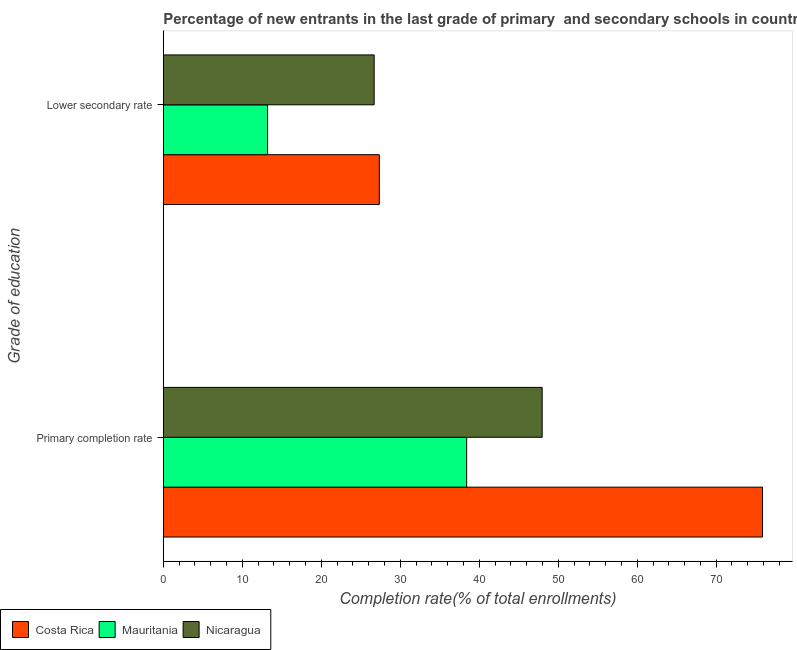How many different coloured bars are there?
Offer a very short reply. 3. How many groups of bars are there?
Provide a short and direct response. 2. How many bars are there on the 2nd tick from the top?
Give a very brief answer. 3. What is the label of the 1st group of bars from the top?
Provide a short and direct response. Lower secondary rate. What is the completion rate in primary schools in Costa Rica?
Your answer should be compact. 75.87. Across all countries, what is the maximum completion rate in primary schools?
Provide a short and direct response. 75.87. Across all countries, what is the minimum completion rate in secondary schools?
Your answer should be compact. 13.21. In which country was the completion rate in primary schools maximum?
Provide a succinct answer. Costa Rica. In which country was the completion rate in secondary schools minimum?
Provide a succinct answer. Mauritania. What is the total completion rate in primary schools in the graph?
Your response must be concise. 162.25. What is the difference between the completion rate in primary schools in Nicaragua and that in Mauritania?
Make the answer very short. 9.56. What is the difference between the completion rate in primary schools in Nicaragua and the completion rate in secondary schools in Mauritania?
Offer a very short reply. 34.76. What is the average completion rate in secondary schools per country?
Your answer should be compact. 22.42. What is the difference between the completion rate in secondary schools and completion rate in primary schools in Nicaragua?
Ensure brevity in your answer.  -21.27. In how many countries, is the completion rate in primary schools greater than 44 %?
Your answer should be very brief. 2. What is the ratio of the completion rate in primary schools in Costa Rica to that in Mauritania?
Your response must be concise. 1.98. What does the 2nd bar from the top in Lower secondary rate represents?
Your answer should be very brief. Mauritania. What does the 3rd bar from the bottom in Primary completion rate represents?
Make the answer very short. Nicaragua. How many countries are there in the graph?
Ensure brevity in your answer.  3. What is the difference between two consecutive major ticks on the X-axis?
Ensure brevity in your answer.  10. Are the values on the major ticks of X-axis written in scientific E-notation?
Make the answer very short. No. Does the graph contain grids?
Provide a short and direct response. No. How many legend labels are there?
Offer a terse response. 3. How are the legend labels stacked?
Make the answer very short. Horizontal. What is the title of the graph?
Give a very brief answer. Percentage of new entrants in the last grade of primary  and secondary schools in countries. What is the label or title of the X-axis?
Make the answer very short. Completion rate(% of total enrollments). What is the label or title of the Y-axis?
Your answer should be compact. Grade of education. What is the Completion rate(% of total enrollments) in Costa Rica in Primary completion rate?
Give a very brief answer. 75.87. What is the Completion rate(% of total enrollments) in Mauritania in Primary completion rate?
Your answer should be very brief. 38.41. What is the Completion rate(% of total enrollments) of Nicaragua in Primary completion rate?
Provide a succinct answer. 47.97. What is the Completion rate(% of total enrollments) in Costa Rica in Lower secondary rate?
Your answer should be compact. 27.35. What is the Completion rate(% of total enrollments) of Mauritania in Lower secondary rate?
Offer a terse response. 13.21. What is the Completion rate(% of total enrollments) in Nicaragua in Lower secondary rate?
Your answer should be compact. 26.7. Across all Grade of education, what is the maximum Completion rate(% of total enrollments) in Costa Rica?
Make the answer very short. 75.87. Across all Grade of education, what is the maximum Completion rate(% of total enrollments) of Mauritania?
Your response must be concise. 38.41. Across all Grade of education, what is the maximum Completion rate(% of total enrollments) of Nicaragua?
Your answer should be compact. 47.97. Across all Grade of education, what is the minimum Completion rate(% of total enrollments) of Costa Rica?
Make the answer very short. 27.35. Across all Grade of education, what is the minimum Completion rate(% of total enrollments) in Mauritania?
Offer a terse response. 13.21. Across all Grade of education, what is the minimum Completion rate(% of total enrollments) of Nicaragua?
Make the answer very short. 26.7. What is the total Completion rate(% of total enrollments) of Costa Rica in the graph?
Your answer should be compact. 103.22. What is the total Completion rate(% of total enrollments) in Mauritania in the graph?
Make the answer very short. 51.62. What is the total Completion rate(% of total enrollments) in Nicaragua in the graph?
Provide a succinct answer. 74.67. What is the difference between the Completion rate(% of total enrollments) in Costa Rica in Primary completion rate and that in Lower secondary rate?
Your answer should be compact. 48.51. What is the difference between the Completion rate(% of total enrollments) of Mauritania in Primary completion rate and that in Lower secondary rate?
Keep it short and to the point. 25.2. What is the difference between the Completion rate(% of total enrollments) of Nicaragua in Primary completion rate and that in Lower secondary rate?
Ensure brevity in your answer.  21.27. What is the difference between the Completion rate(% of total enrollments) in Costa Rica in Primary completion rate and the Completion rate(% of total enrollments) in Mauritania in Lower secondary rate?
Your answer should be very brief. 62.66. What is the difference between the Completion rate(% of total enrollments) of Costa Rica in Primary completion rate and the Completion rate(% of total enrollments) of Nicaragua in Lower secondary rate?
Provide a succinct answer. 49.17. What is the difference between the Completion rate(% of total enrollments) of Mauritania in Primary completion rate and the Completion rate(% of total enrollments) of Nicaragua in Lower secondary rate?
Offer a terse response. 11.71. What is the average Completion rate(% of total enrollments) of Costa Rica per Grade of education?
Ensure brevity in your answer.  51.61. What is the average Completion rate(% of total enrollments) of Mauritania per Grade of education?
Provide a short and direct response. 25.81. What is the average Completion rate(% of total enrollments) of Nicaragua per Grade of education?
Give a very brief answer. 37.33. What is the difference between the Completion rate(% of total enrollments) in Costa Rica and Completion rate(% of total enrollments) in Mauritania in Primary completion rate?
Offer a very short reply. 37.46. What is the difference between the Completion rate(% of total enrollments) in Costa Rica and Completion rate(% of total enrollments) in Nicaragua in Primary completion rate?
Make the answer very short. 27.9. What is the difference between the Completion rate(% of total enrollments) of Mauritania and Completion rate(% of total enrollments) of Nicaragua in Primary completion rate?
Provide a short and direct response. -9.56. What is the difference between the Completion rate(% of total enrollments) of Costa Rica and Completion rate(% of total enrollments) of Mauritania in Lower secondary rate?
Provide a succinct answer. 14.15. What is the difference between the Completion rate(% of total enrollments) of Costa Rica and Completion rate(% of total enrollments) of Nicaragua in Lower secondary rate?
Your answer should be very brief. 0.65. What is the difference between the Completion rate(% of total enrollments) of Mauritania and Completion rate(% of total enrollments) of Nicaragua in Lower secondary rate?
Offer a terse response. -13.49. What is the ratio of the Completion rate(% of total enrollments) of Costa Rica in Primary completion rate to that in Lower secondary rate?
Your response must be concise. 2.77. What is the ratio of the Completion rate(% of total enrollments) of Mauritania in Primary completion rate to that in Lower secondary rate?
Your answer should be compact. 2.91. What is the ratio of the Completion rate(% of total enrollments) in Nicaragua in Primary completion rate to that in Lower secondary rate?
Provide a succinct answer. 1.8. What is the difference between the highest and the second highest Completion rate(% of total enrollments) in Costa Rica?
Ensure brevity in your answer.  48.51. What is the difference between the highest and the second highest Completion rate(% of total enrollments) in Mauritania?
Provide a succinct answer. 25.2. What is the difference between the highest and the second highest Completion rate(% of total enrollments) of Nicaragua?
Your response must be concise. 21.27. What is the difference between the highest and the lowest Completion rate(% of total enrollments) in Costa Rica?
Make the answer very short. 48.51. What is the difference between the highest and the lowest Completion rate(% of total enrollments) in Mauritania?
Your answer should be very brief. 25.2. What is the difference between the highest and the lowest Completion rate(% of total enrollments) of Nicaragua?
Keep it short and to the point. 21.27. 